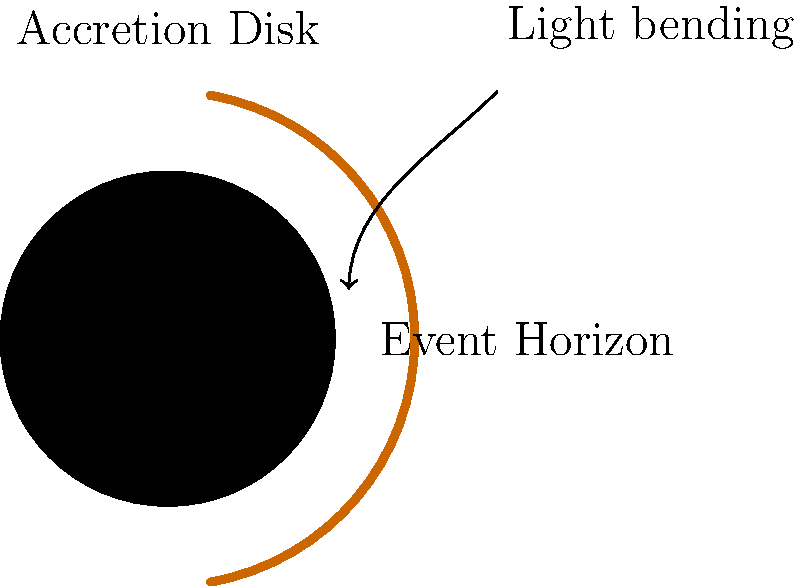In the context of international cooperation on space exploration, how does the structure of a black hole's event horizon relate to the concept of "point of no return" in diplomacy? Explain using the diagram and your understanding of both astronomy and global politics. To answer this question, let's break it down step-by-step:

1. Black Hole Structure:
   - The diagram shows a black hole with its key components: the singularity at the center, the event horizon surrounding it, and the accretion disk.
   - The event horizon is the boundary beyond which nothing, not even light, can escape the black hole's gravitational pull.

2. Event Horizon as "Point of No Return":
   - In astronomy, the event horizon represents a critical threshold. Once an object crosses this boundary, it cannot return or communicate with the outside universe.
   - The formula for the radius of the event horizon (Schwarzschild radius) is:
     $$R_s = \frac{2GM}{c^2}$$
     where $G$ is the gravitational constant, $M$ is the mass of the black hole, and $c$ is the speed of light.

3. Diplomatic "Point of No Return":
   - In international relations, a "point of no return" refers to a critical moment in negotiations or conflicts where decisions become irreversible.
   - Examples include declaring war, imposing severe sanctions, or breaking diplomatic ties.

4. Parallels between Event Horizon and Diplomacy:
   a) Irreversibility: Both concepts involve crossing a threshold beyond which actions cannot be undone.
   b) Information loss: In a black hole, information is lost once it crosses the event horizon. Similarly, in diplomacy, certain actions can lead to a breakdown in communication.
   c) Gravitational influence: A black hole's gravity affects nearby objects, much like how powerful nations influence smaller countries in international politics.

5. International Cooperation in Space Exploration:
   - Space exploration, including black hole research, often requires international collaboration (e.g., Event Horizon Telescope project).
   - Understanding black holes can serve as a metaphor for navigating complex international relationships and avoiding diplomatic "points of no return."

6. Application to Global Politics:
   - Just as scientists must carefully approach the study of black holes, diplomats must cautiously navigate international negotiations to avoid crossing irreversible thresholds.
   - The concept of an event horizon can be used to analyze potential consequences of political decisions in international relations.
Answer: The event horizon, as a "point of no return" in black holes, parallels irreversible diplomatic actions in international relations, emphasizing the need for cautious navigation in both space exploration and global politics. 